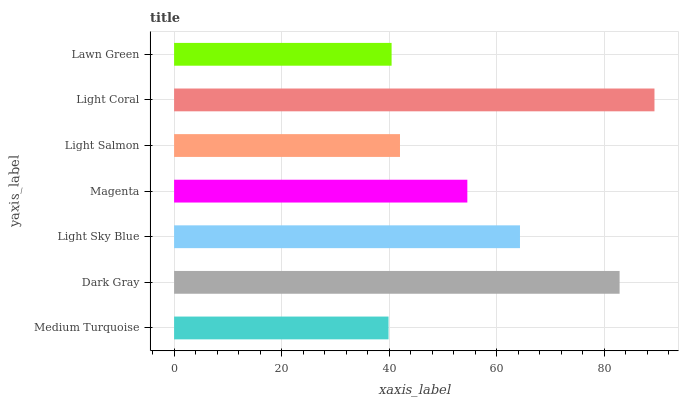Is Medium Turquoise the minimum?
Answer yes or no. Yes. Is Light Coral the maximum?
Answer yes or no. Yes. Is Dark Gray the minimum?
Answer yes or no. No. Is Dark Gray the maximum?
Answer yes or no. No. Is Dark Gray greater than Medium Turquoise?
Answer yes or no. Yes. Is Medium Turquoise less than Dark Gray?
Answer yes or no. Yes. Is Medium Turquoise greater than Dark Gray?
Answer yes or no. No. Is Dark Gray less than Medium Turquoise?
Answer yes or no. No. Is Magenta the high median?
Answer yes or no. Yes. Is Magenta the low median?
Answer yes or no. Yes. Is Light Sky Blue the high median?
Answer yes or no. No. Is Lawn Green the low median?
Answer yes or no. No. 